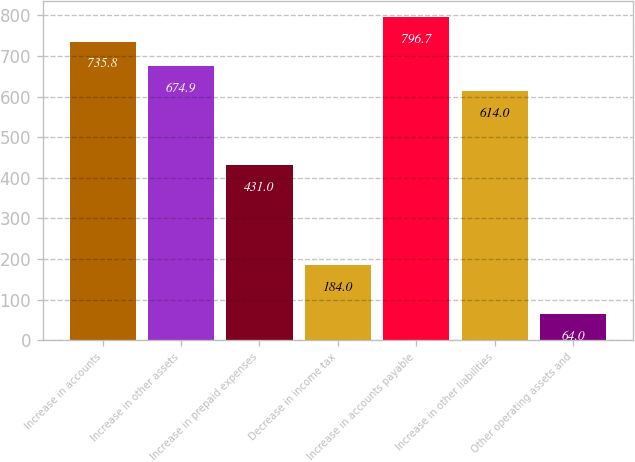<chart> <loc_0><loc_0><loc_500><loc_500><bar_chart><fcel>Increase in accounts<fcel>Increase in other assets<fcel>Increase in prepaid expenses<fcel>Decrease in income tax<fcel>Increase in accounts payable<fcel>Increase in other liabilities<fcel>Other operating assets and<nl><fcel>735.8<fcel>674.9<fcel>431<fcel>184<fcel>796.7<fcel>614<fcel>64<nl></chart> 